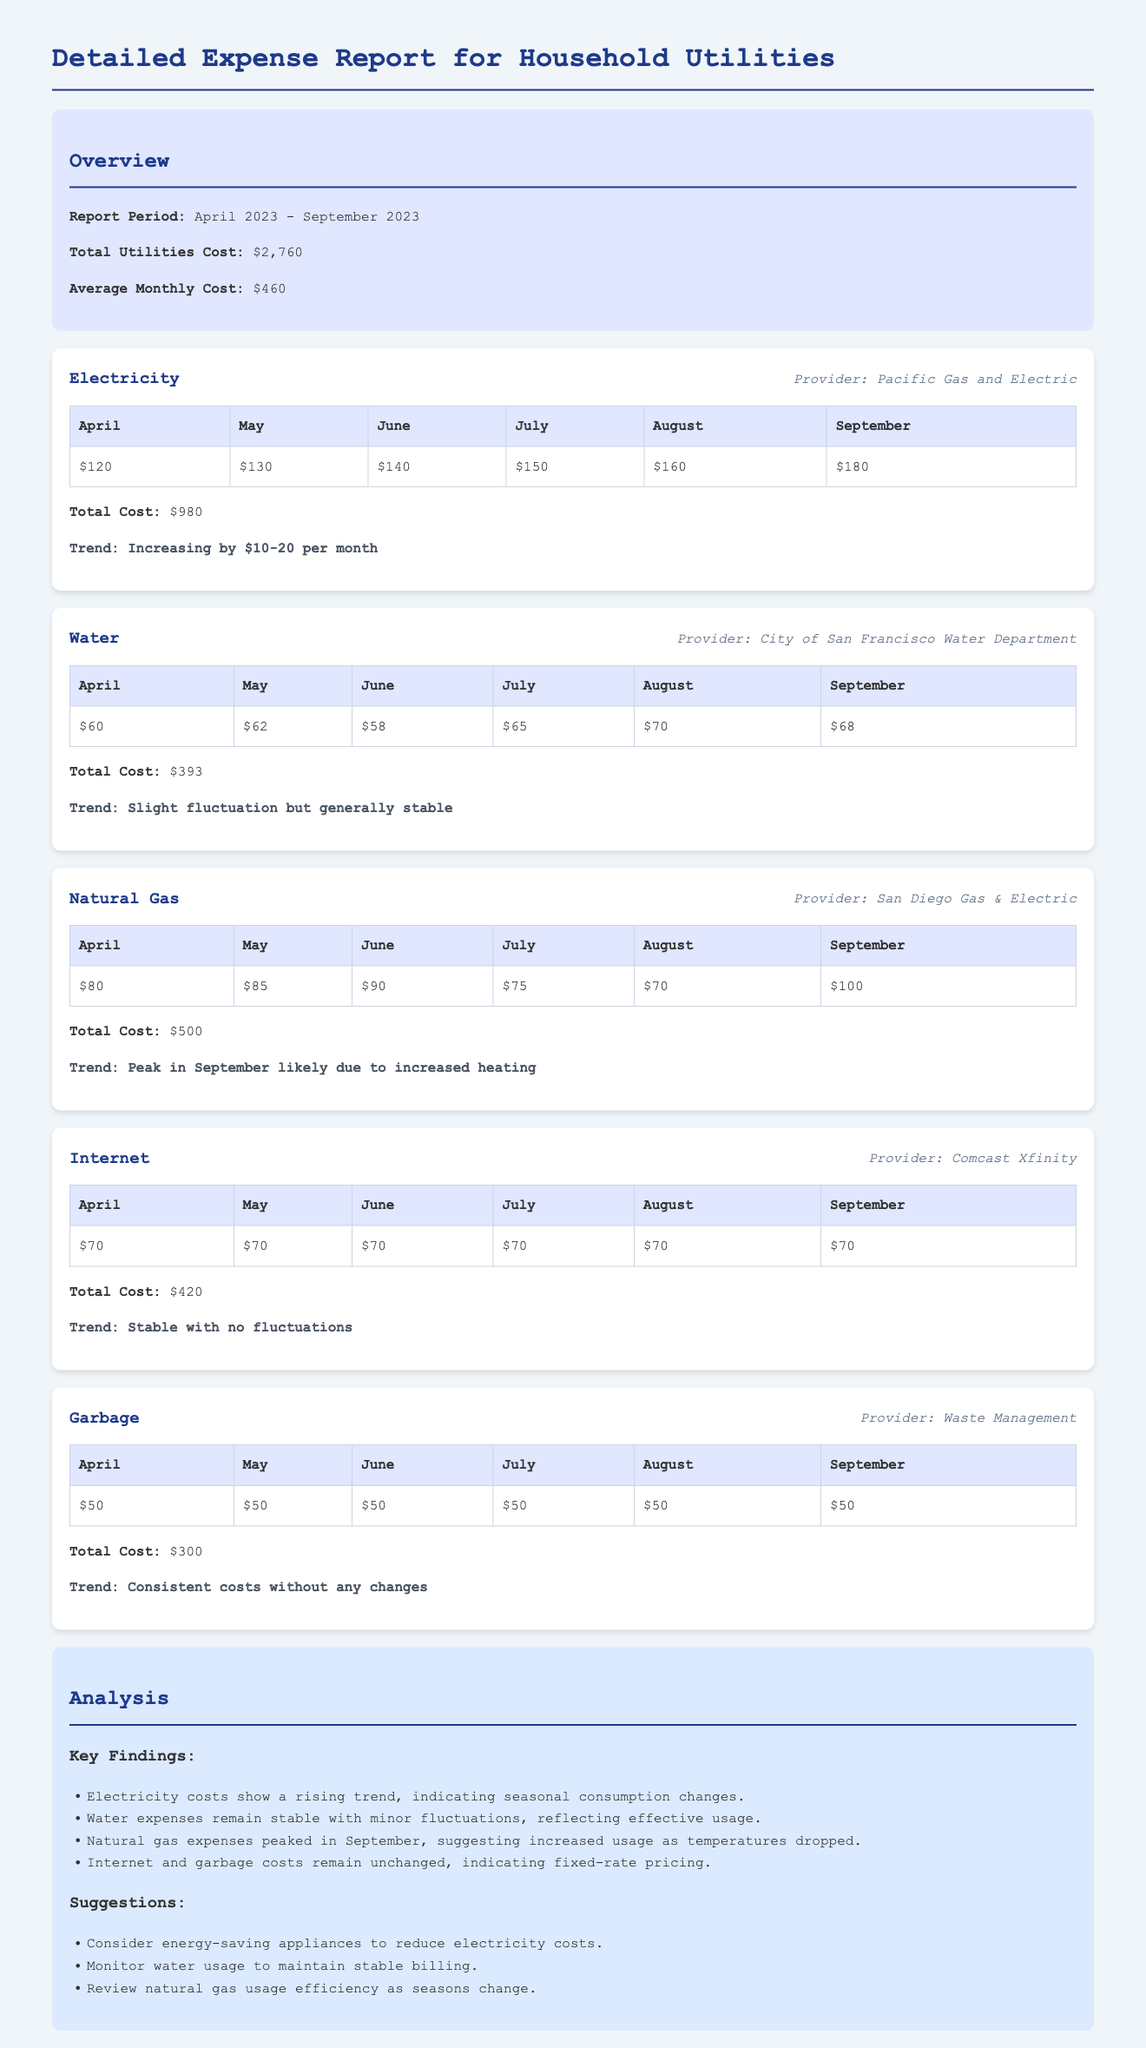What is the total utilities cost? The total utilities cost is the aggregate of all utility expenses for the specified period, which is stated in the overview section of the report.
Answer: $2,760 What is the average monthly cost of utilities? The average monthly cost is calculated by dividing the total utilities cost by the number of months in the report period, which is also noted in the overview section.
Answer: $460 Which utility has the highest total cost? By examining the total costs for each utility provided in the report, we can identify which utility incurred the highest expense during the period.
Answer: Electricity What was the total cost for water? The total cost for water can be found in the water utility section, summarizing expenses for this specific service over six months.
Answer: $393 In which month did natural gas expenses peak? The peak month for natural gas expenses is indicated in the trend section, where it mentions the highest monthly cost for that utility.
Answer: September What trend is observed for electricity costs? The trend section for electricity describes the monthly changes in costs, illustrating the overall behavior of expenses during the report period.
Answer: Increasing by $10-20 per month How many months did the Internet cost remain stable? By analyzing the Internet section, we can see how many months had unchanged costs, reflecting its pricing model.
Answer: 6 What is one suggestion provided in the analysis section? Specific suggestions can be found in the analysis section, which offers advice based on the utility costs observed in the report.
Answer: Consider energy-saving appliances to reduce electricity costs What is the provider for garbage services? The provider for garbage services is listed in the garbage utility section, representing the company in charge of this utility.
Answer: Waste Management 